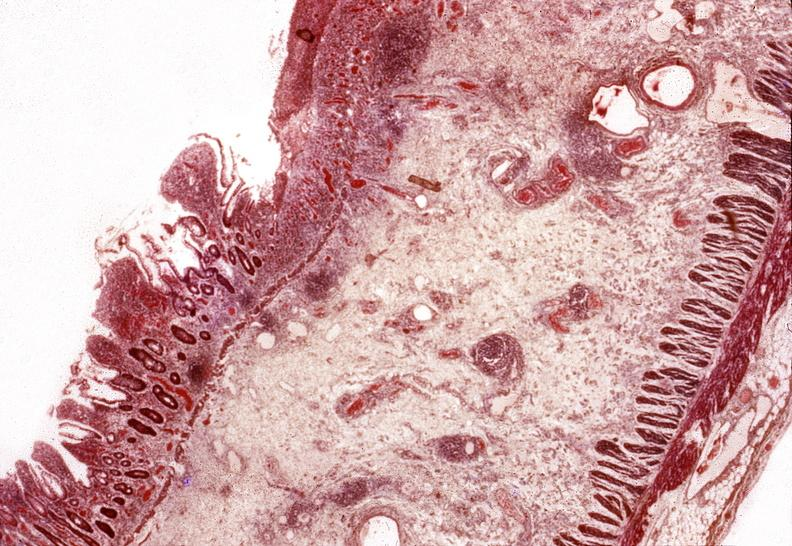does this image show small intestine, regional enteritis?
Answer the question using a single word or phrase. Yes 